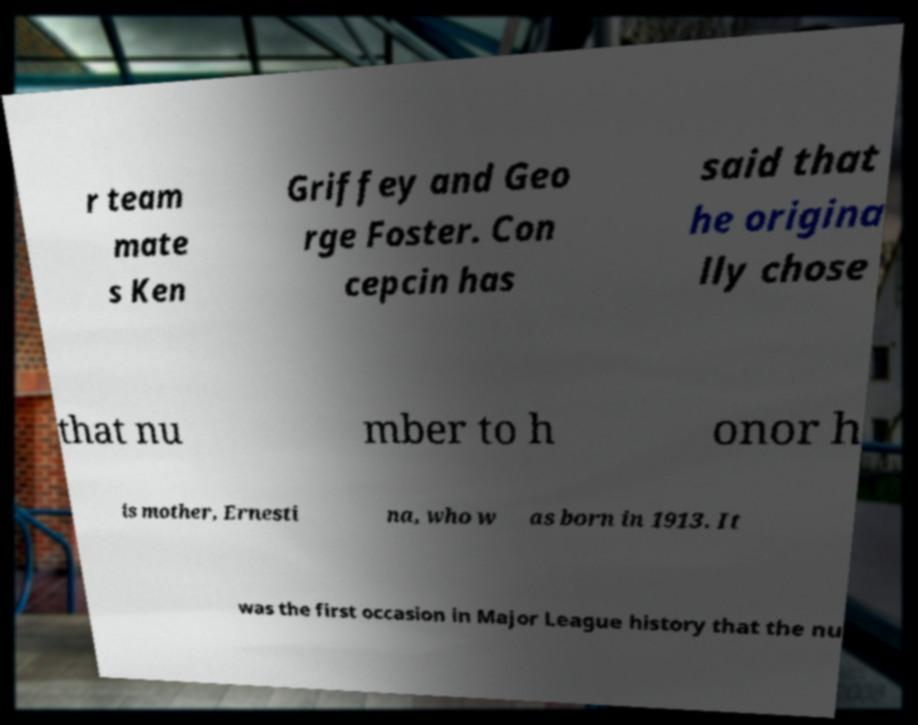Please identify and transcribe the text found in this image. r team mate s Ken Griffey and Geo rge Foster. Con cepcin has said that he origina lly chose that nu mber to h onor h is mother, Ernesti na, who w as born in 1913. It was the first occasion in Major League history that the nu 